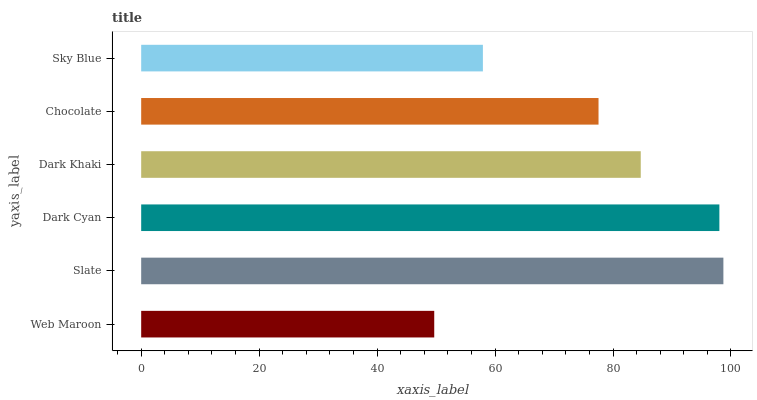Is Web Maroon the minimum?
Answer yes or no. Yes. Is Slate the maximum?
Answer yes or no. Yes. Is Dark Cyan the minimum?
Answer yes or no. No. Is Dark Cyan the maximum?
Answer yes or no. No. Is Slate greater than Dark Cyan?
Answer yes or no. Yes. Is Dark Cyan less than Slate?
Answer yes or no. Yes. Is Dark Cyan greater than Slate?
Answer yes or no. No. Is Slate less than Dark Cyan?
Answer yes or no. No. Is Dark Khaki the high median?
Answer yes or no. Yes. Is Chocolate the low median?
Answer yes or no. Yes. Is Sky Blue the high median?
Answer yes or no. No. Is Dark Khaki the low median?
Answer yes or no. No. 